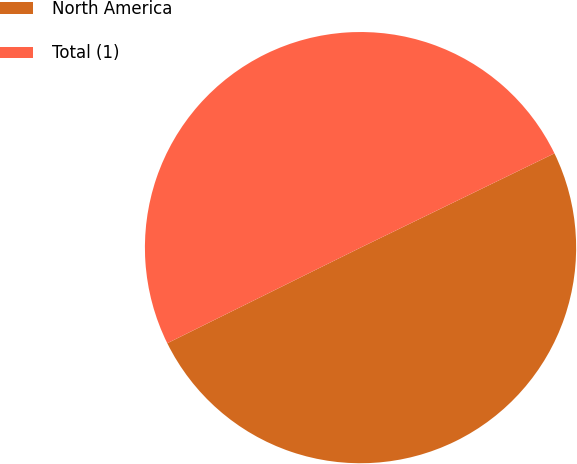Convert chart to OTSL. <chart><loc_0><loc_0><loc_500><loc_500><pie_chart><fcel>North America<fcel>Total (1)<nl><fcel>49.89%<fcel>50.11%<nl></chart> 